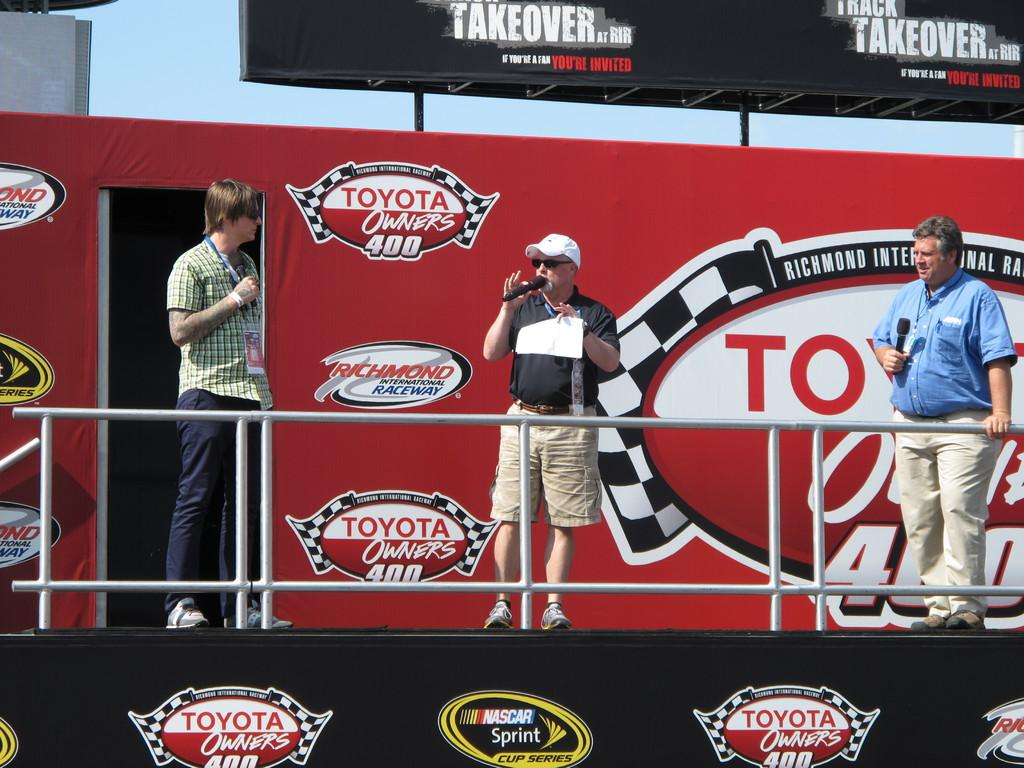<image>
Describe the image concisely. Three men stand on a platform of a structure bearing a logo for the Toyota Owner's 400 race. 